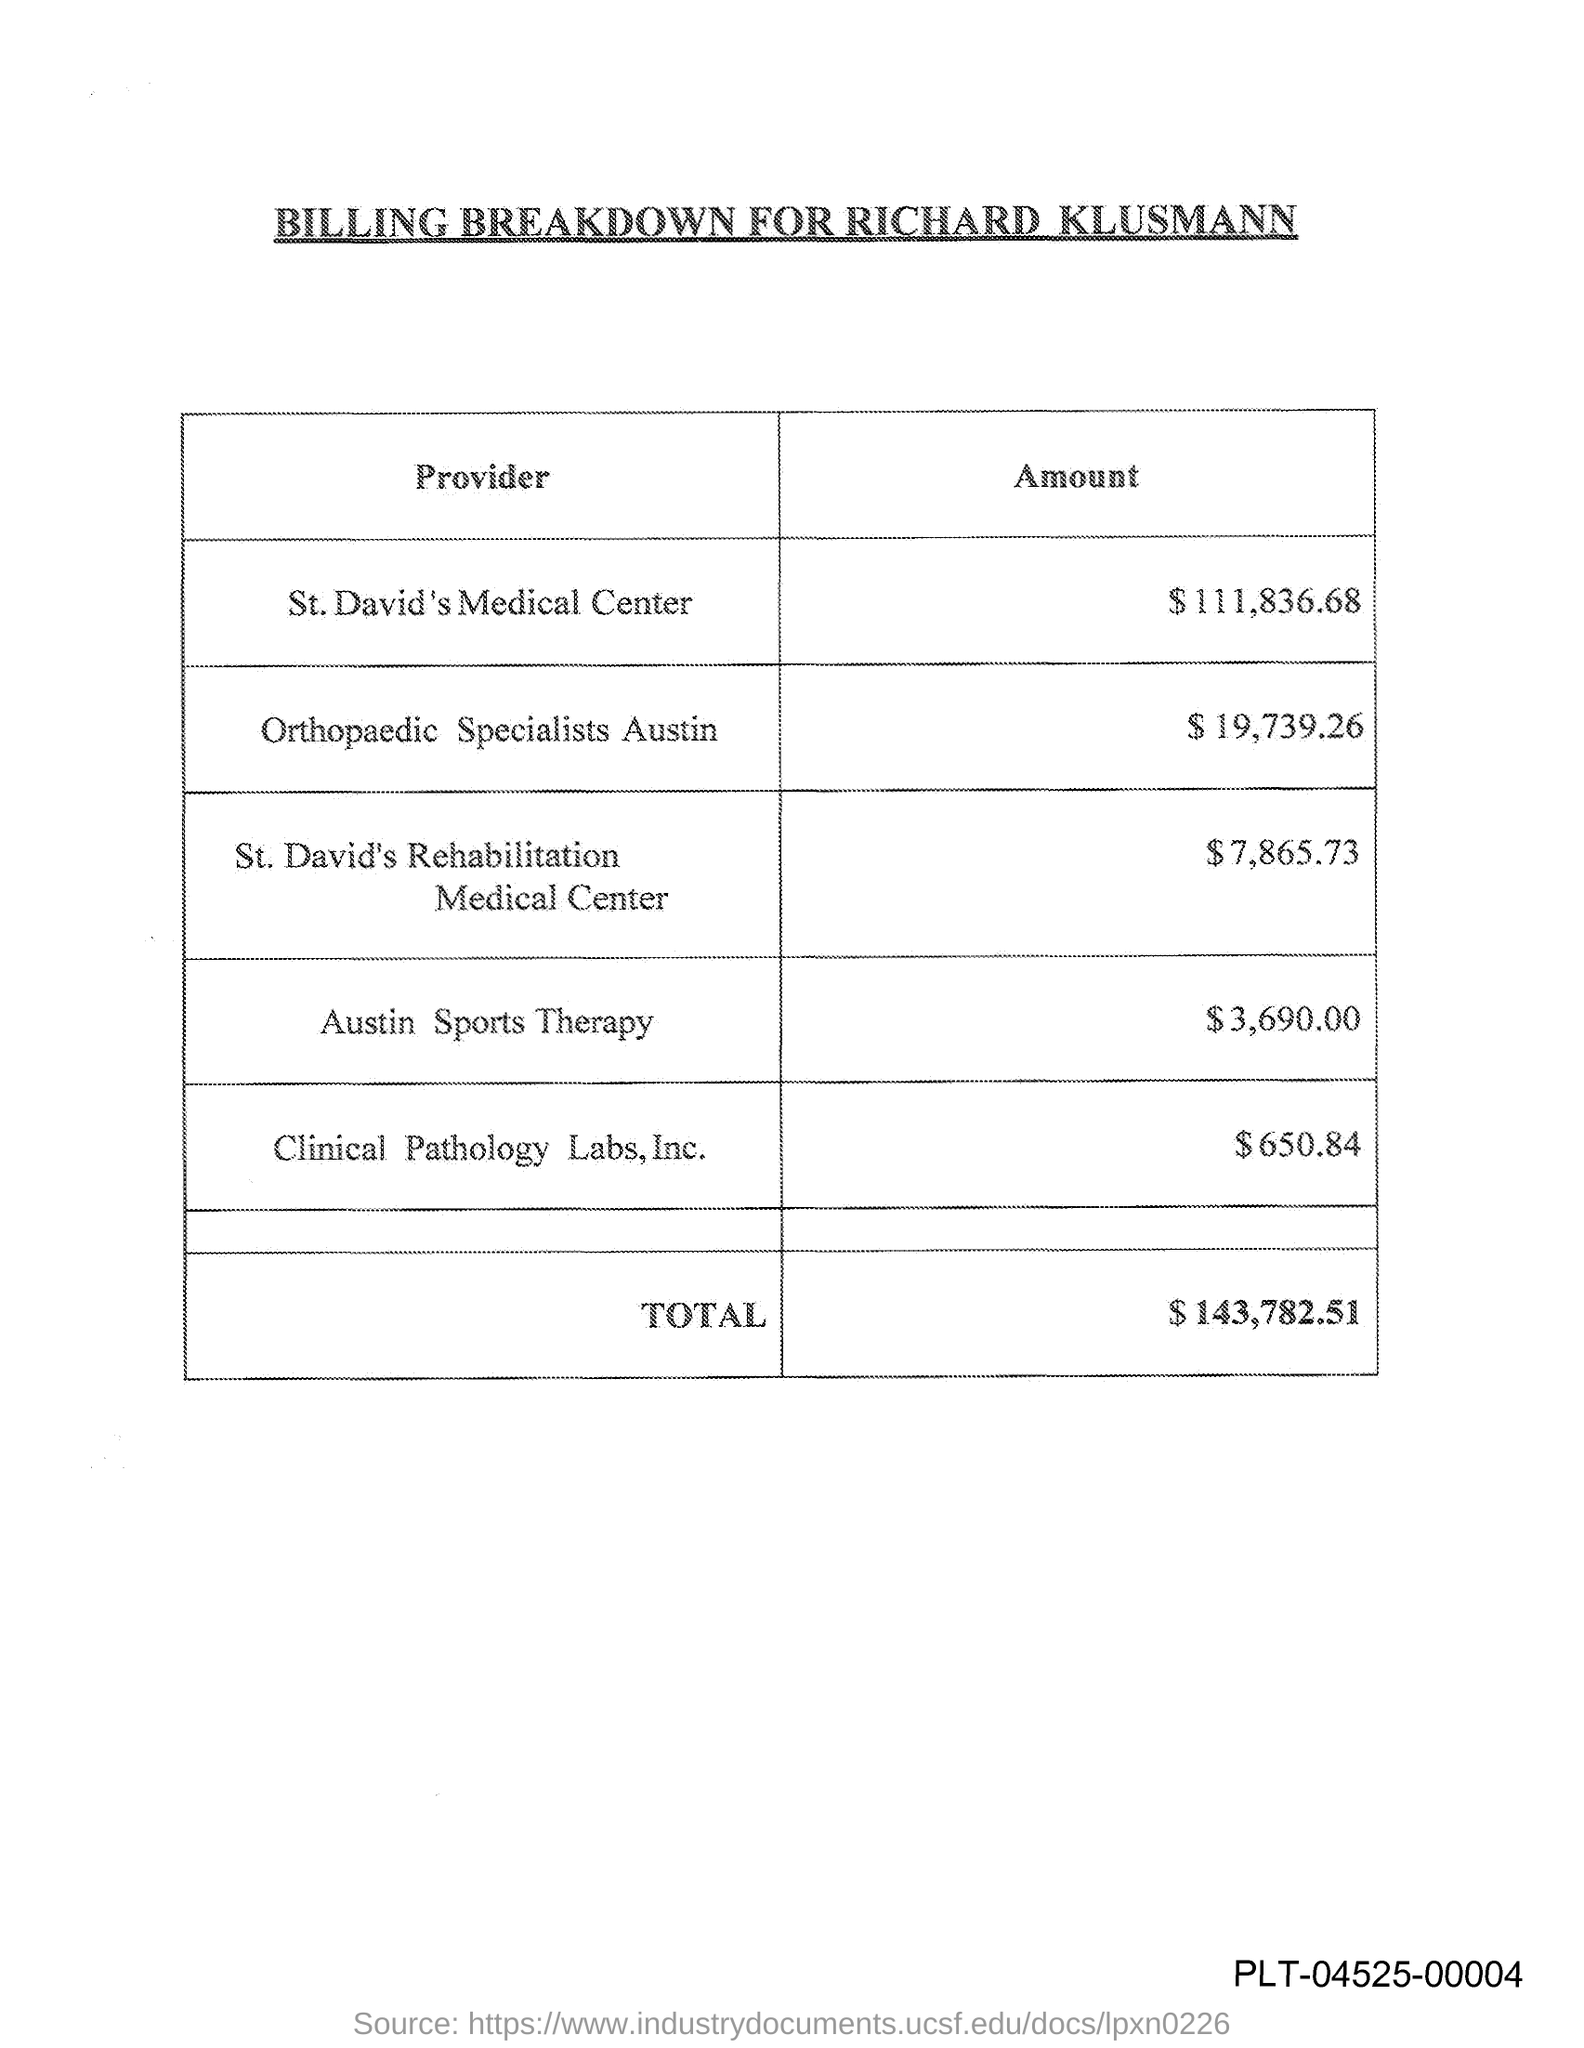Mention a couple of crucial points in this snapshot. The total amount is 143,782.51 dollars. The title of the document is "Billing breakdown for Richard Klusmann. 